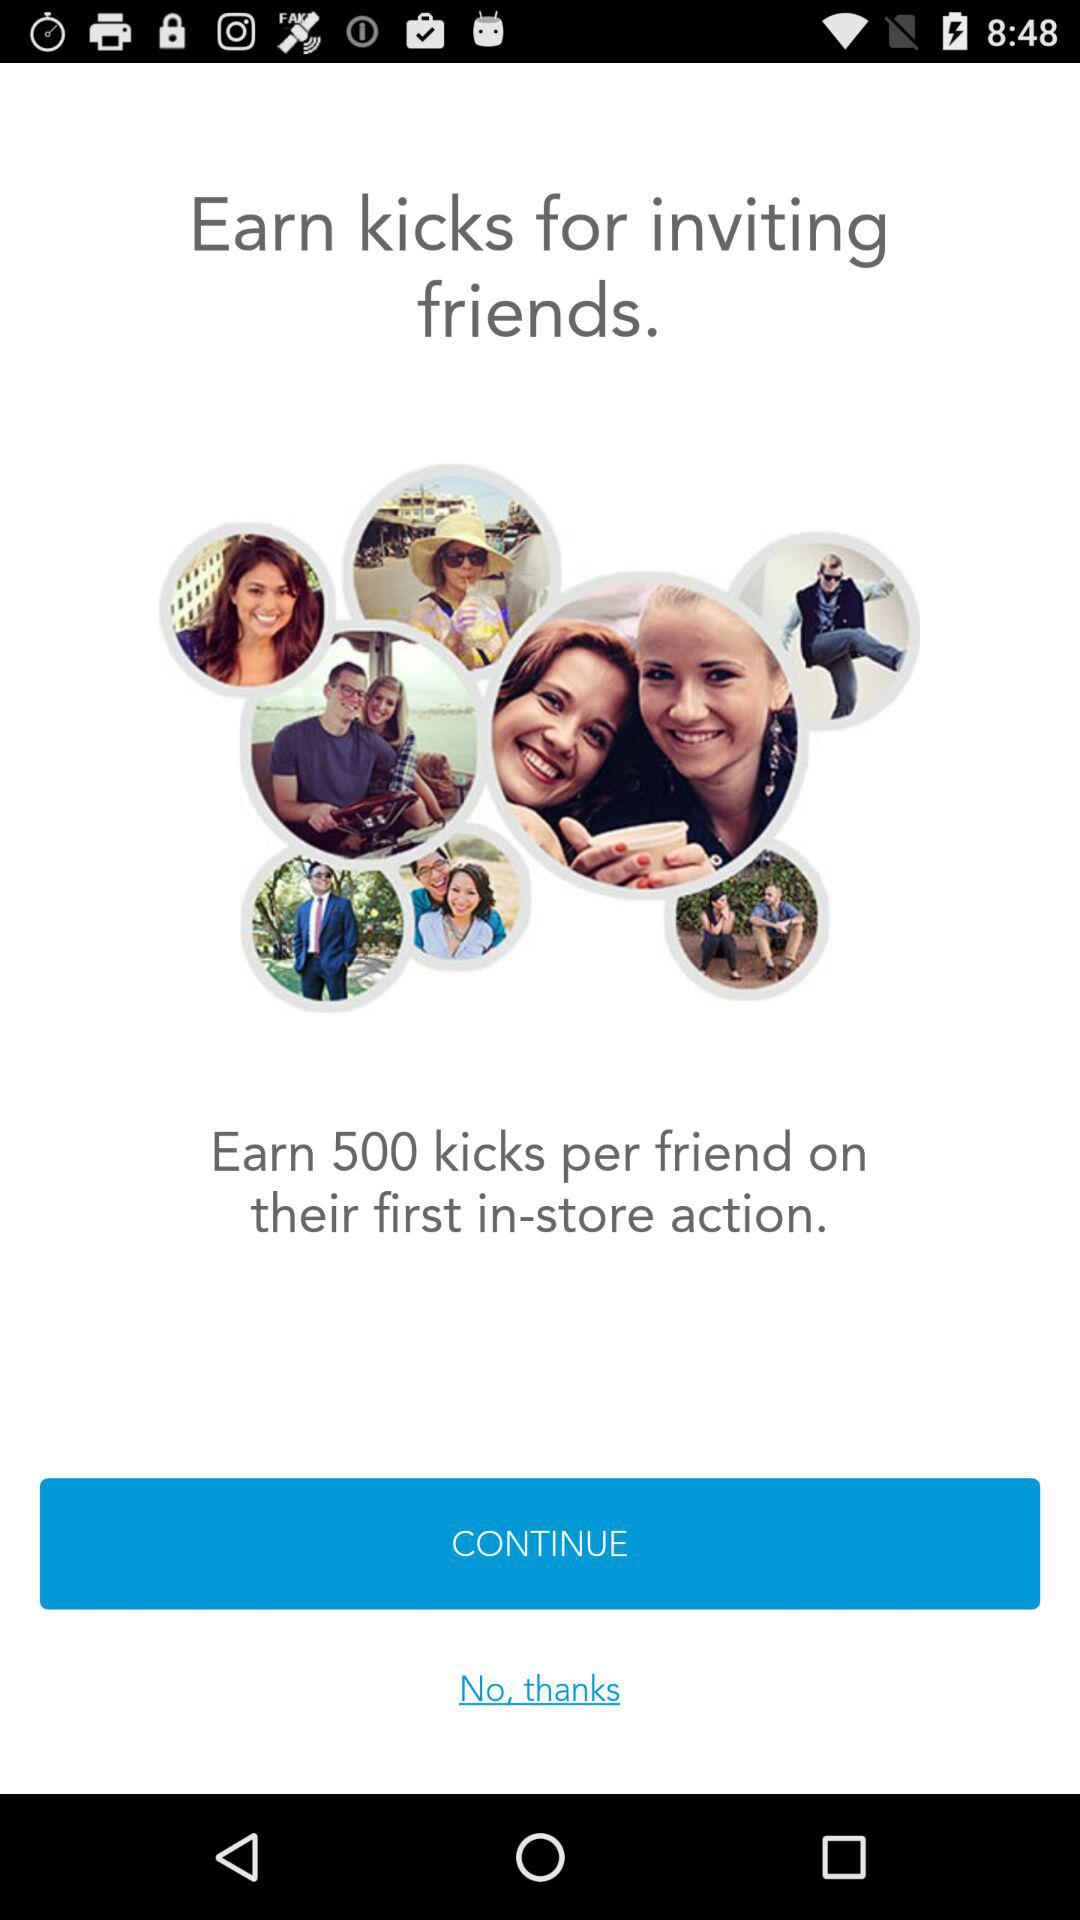How many kicks do you earn for each friend that takes their first in-store action?
Answer the question using a single word or phrase. 500 